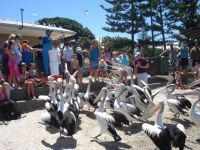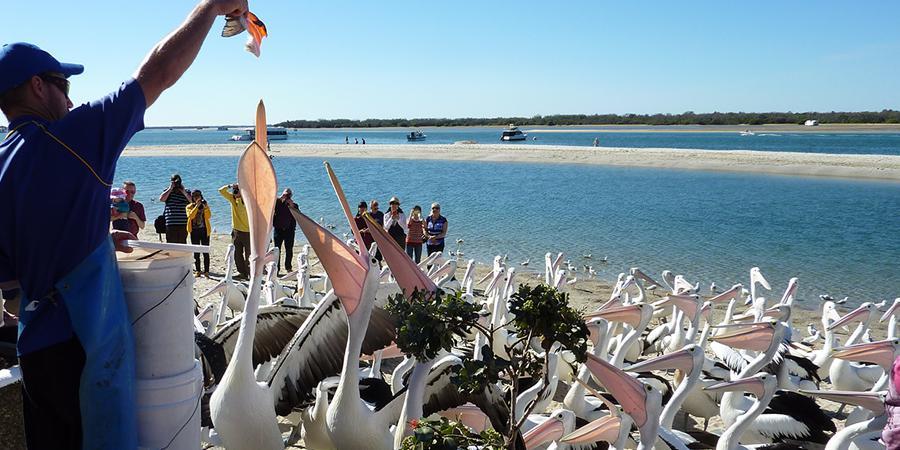The first image is the image on the left, the second image is the image on the right. Considering the images on both sides, is "At least one pelican has its mouth open." valid? Answer yes or no. Yes. The first image is the image on the left, the second image is the image on the right. For the images shown, is this caption "In one of the photos in each pair is a man in a blue shirt surrounded by many pelicans and he is feeding them." true? Answer yes or no. Yes. 